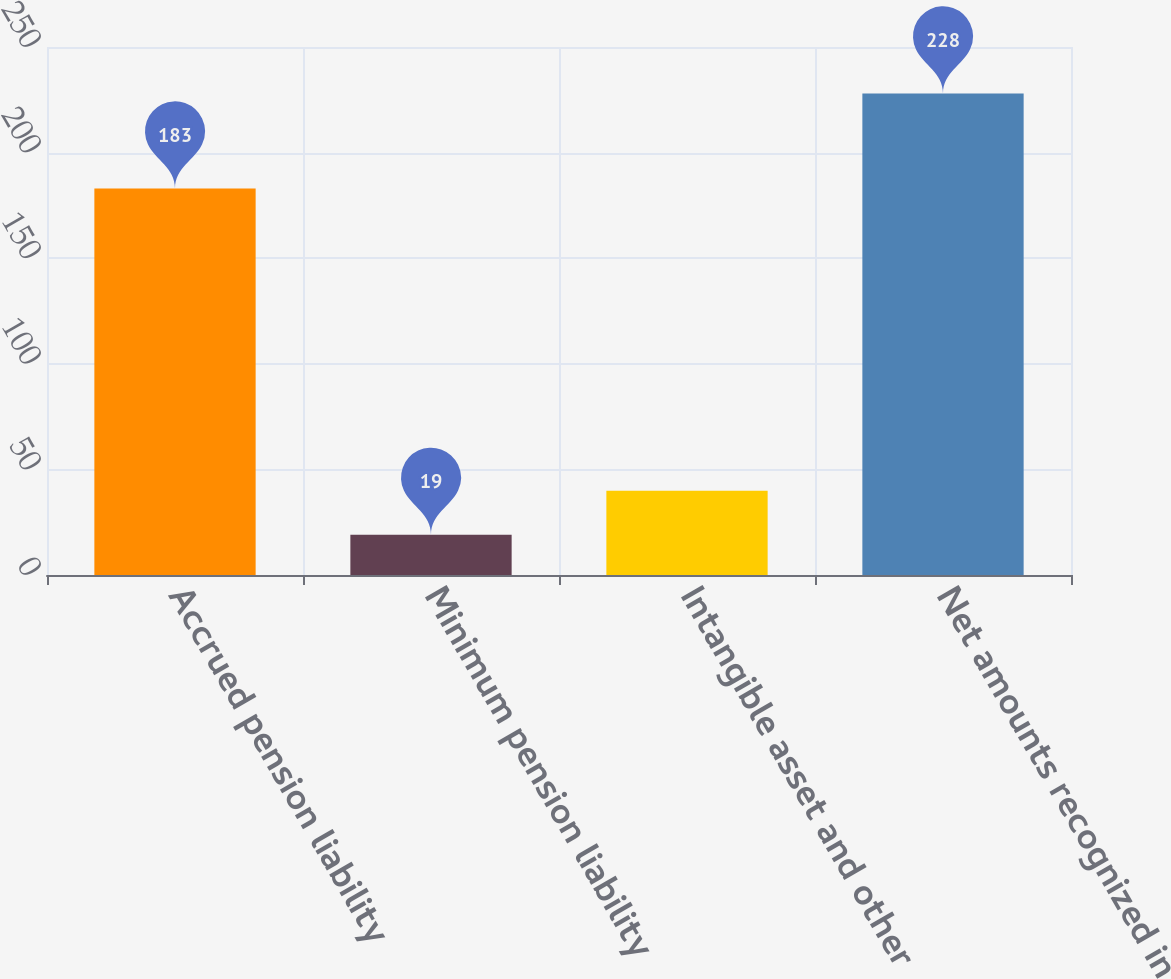<chart> <loc_0><loc_0><loc_500><loc_500><bar_chart><fcel>Accrued pension liability<fcel>Minimum pension liability<fcel>Intangible asset and other<fcel>Net amounts recognized in<nl><fcel>183<fcel>19<fcel>39.9<fcel>228<nl></chart> 